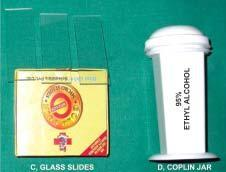s equipments required for transcutaneous fnac?
Answer the question using a single word or phrase. Yes 